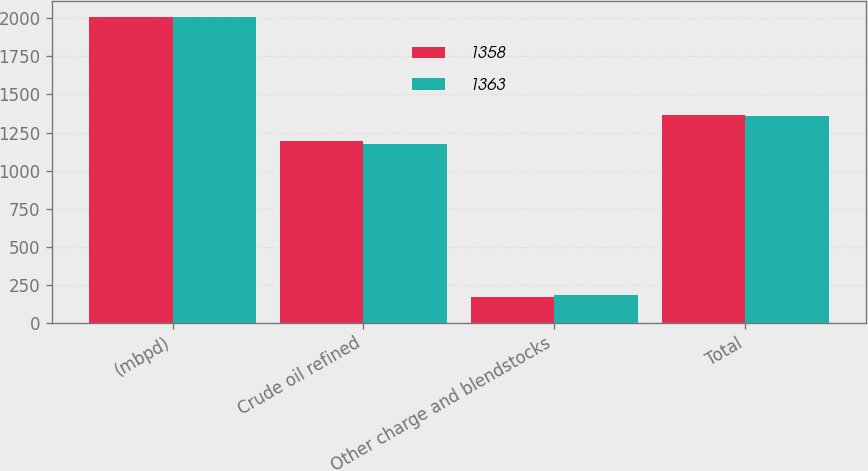Convert chart to OTSL. <chart><loc_0><loc_0><loc_500><loc_500><stacked_bar_chart><ecel><fcel>(mbpd)<fcel>Crude oil refined<fcel>Other charge and blendstocks<fcel>Total<nl><fcel>1358<fcel>2012<fcel>1195<fcel>168<fcel>1363<nl><fcel>1363<fcel>2011<fcel>1177<fcel>181<fcel>1358<nl></chart> 